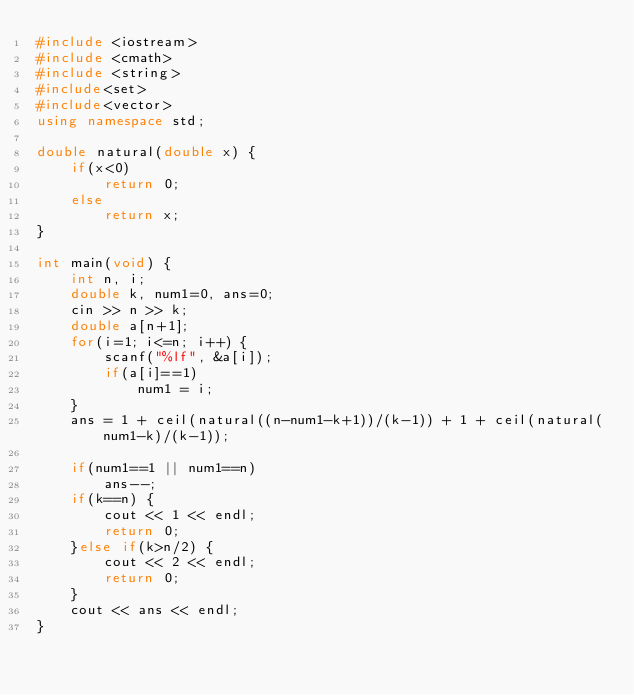<code> <loc_0><loc_0><loc_500><loc_500><_C++_>#include <iostream>
#include <cmath>
#include <string>
#include<set>
#include<vector>
using namespace std;

double natural(double x) {
    if(x<0)
        return 0;
    else
        return x;
}

int main(void) {
    int n, i;
    double k, num1=0, ans=0;
    cin >> n >> k;
    double a[n+1];
    for(i=1; i<=n; i++) {
        scanf("%lf", &a[i]);
        if(a[i]==1)
            num1 = i;
    }
    ans = 1 + ceil(natural((n-num1-k+1))/(k-1)) + 1 + ceil(natural(num1-k)/(k-1));
    
    if(num1==1 || num1==n)
        ans--;
    if(k==n) {
        cout << 1 << endl;
        return 0;
    }else if(k>n/2) {
        cout << 2 << endl;
        return 0;
    }
    cout << ans << endl;
}
</code> 